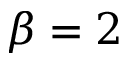Convert formula to latex. <formula><loc_0><loc_0><loc_500><loc_500>\beta = 2</formula> 